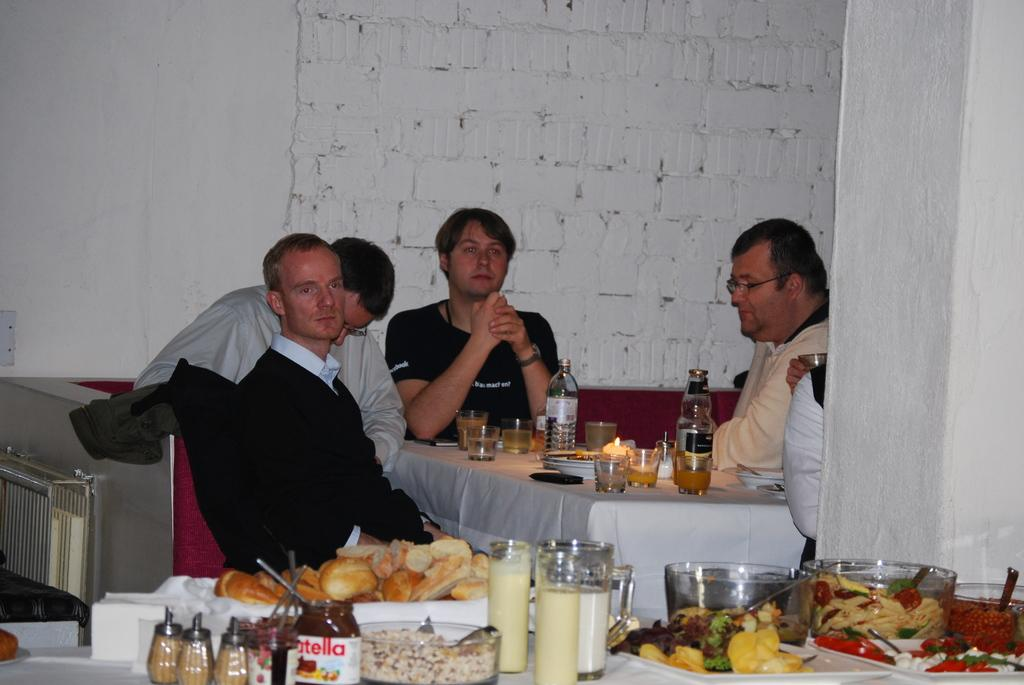<image>
Render a clear and concise summary of the photo. A man with a black t-shirt with the words "macht en" sits at a table. 